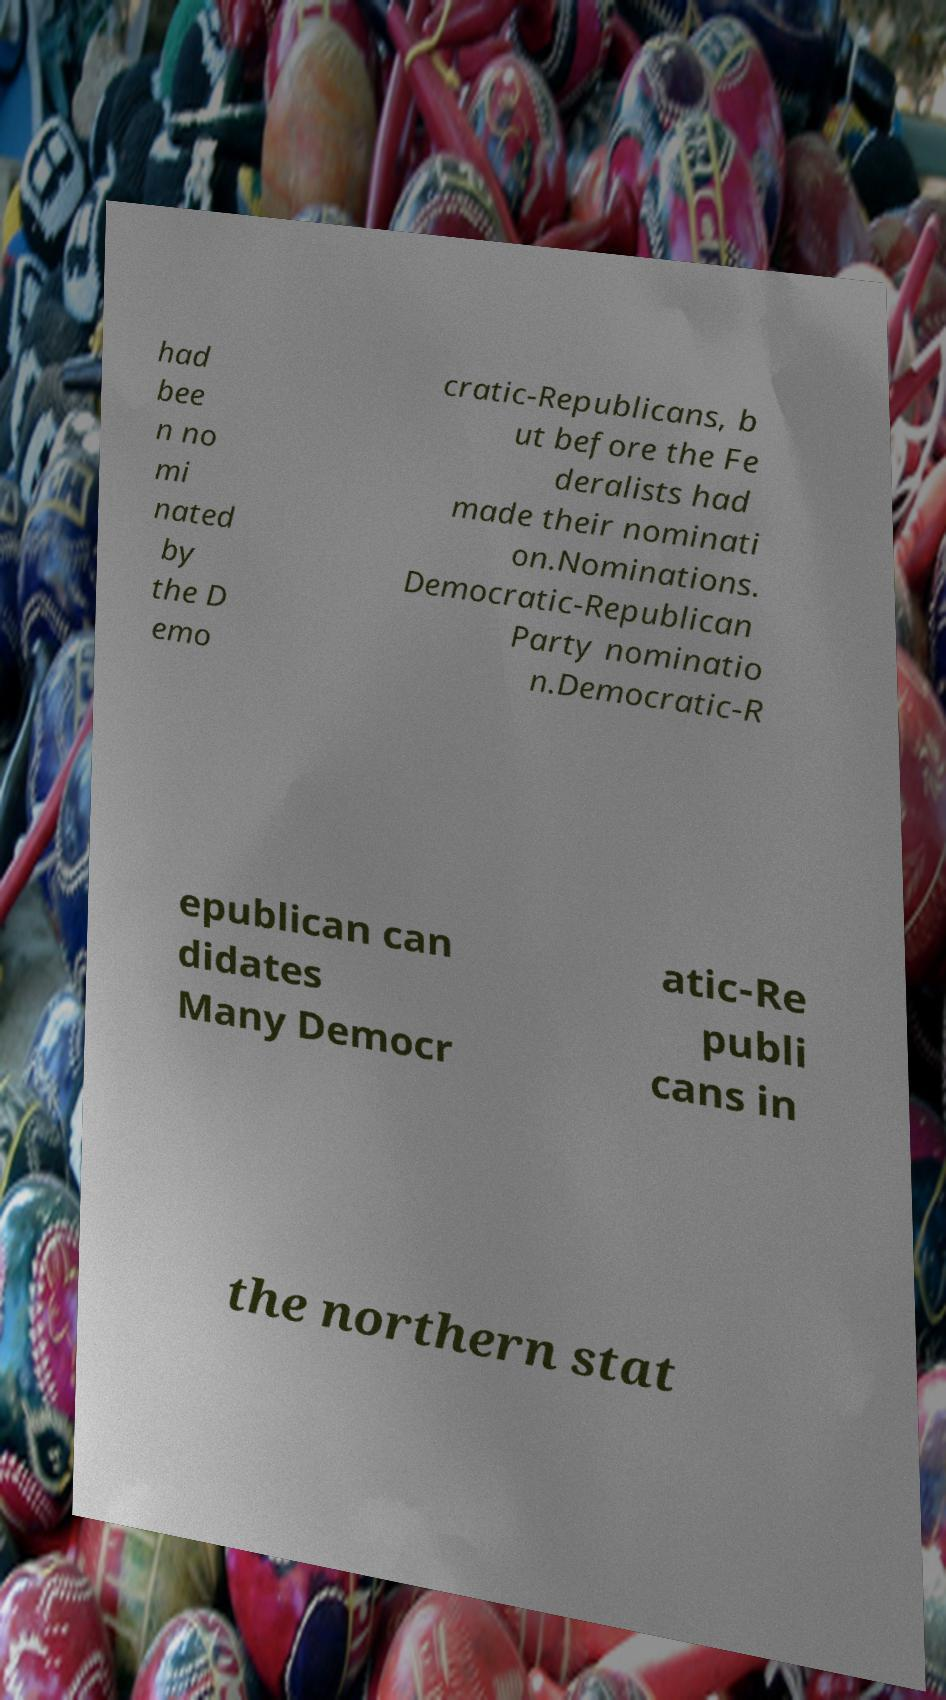Could you assist in decoding the text presented in this image and type it out clearly? had bee n no mi nated by the D emo cratic-Republicans, b ut before the Fe deralists had made their nominati on.Nominations. Democratic-Republican Party nominatio n.Democratic-R epublican can didates Many Democr atic-Re publi cans in the northern stat 